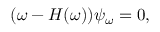Convert formula to latex. <formula><loc_0><loc_0><loc_500><loc_500>( \omega - H ( \omega ) ) \psi _ { \omega } = 0 ,</formula> 